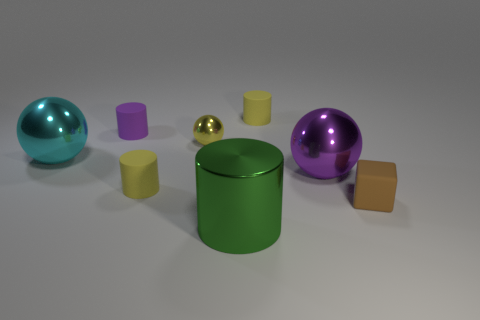Subtract all tiny yellow metallic spheres. How many spheres are left? 2 Add 1 small red cubes. How many objects exist? 9 Subtract all yellow cylinders. How many cylinders are left? 2 Subtract 1 cylinders. How many cylinders are left? 3 Subtract all green spheres. How many purple cylinders are left? 1 Subtract all small green rubber cylinders. Subtract all yellow things. How many objects are left? 5 Add 2 shiny objects. How many shiny objects are left? 6 Add 1 tiny purple rubber cylinders. How many tiny purple rubber cylinders exist? 2 Subtract 0 gray cylinders. How many objects are left? 8 Subtract all balls. How many objects are left? 5 